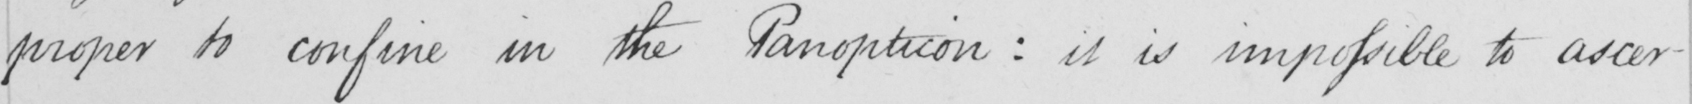Can you tell me what this handwritten text says? proper to confine in the Panopticon :  it is impossible to ascer- 